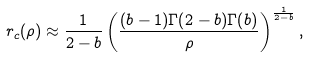<formula> <loc_0><loc_0><loc_500><loc_500>r _ { c } ( \rho ) \approx \frac { 1 } { 2 - b } \left ( \frac { ( b - 1 ) \Gamma ( 2 - b ) \Gamma ( b ) } { \rho } \right ) ^ { \frac { 1 } { 2 - b } } ,</formula> 